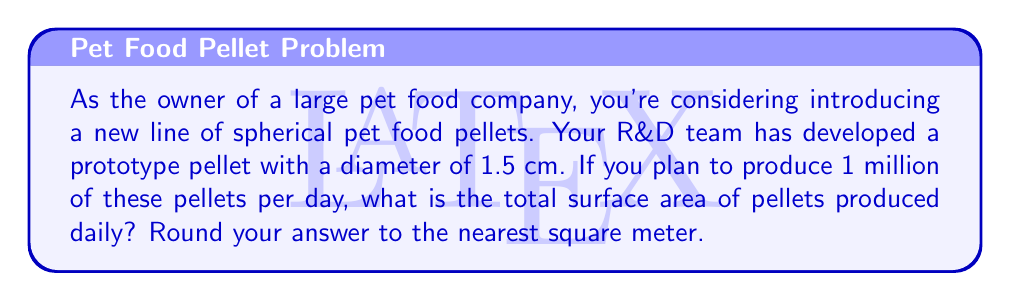Teach me how to tackle this problem. To solve this problem, we need to follow these steps:

1. Calculate the surface area of a single spherical pellet:
   The formula for the surface area of a sphere is $A = 4\pi r^2$, where $r$ is the radius.
   
   Diameter = 1.5 cm, so radius = 0.75 cm = 0.0075 m
   
   $$A = 4\pi (0.0075\text{ m})^2 = 4\pi (0.0000562500\text{ m}^2) = 0.0007068583\text{ m}^2$$

2. Calculate the total surface area for 1 million pellets:
   $$\text{Total Area} = 0.0007068583\text{ m}^2 \times 1,000,000 = 706.8583\text{ m}^2$$

3. Round to the nearest square meter:
   706.8583 m² rounds to 707 m²

[asy]
import geometry;

size(100);
draw(circle((0,0),1), linewidth(0.8));
draw((-1,0)--(1,0),dashed);
draw((0,0)--(1,0),Arrow);
label("r", (0.5,0.2));
label("d", (0,-1.2));
draw((-1.2,-1.2)--(1.2,-1.2),Arrow(6));
[/asy]

This calculation is crucial for determining the amount of coating or seasoning needed for the pellets, as well as for estimating packaging requirements and production capacity.
Answer: 707 m² 